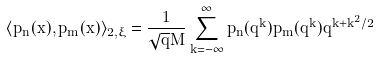Convert formula to latex. <formula><loc_0><loc_0><loc_500><loc_500>\langle p _ { n } ( x ) , p _ { m } ( x ) \rangle _ { 2 , \xi } = \frac { 1 } { \sqrt { q } M } \sum _ { k = - \infty } ^ { \infty } p _ { n } ( q ^ { k } ) p _ { m } ( q ^ { k } ) q ^ { k + k ^ { 2 } / 2 }</formula> 